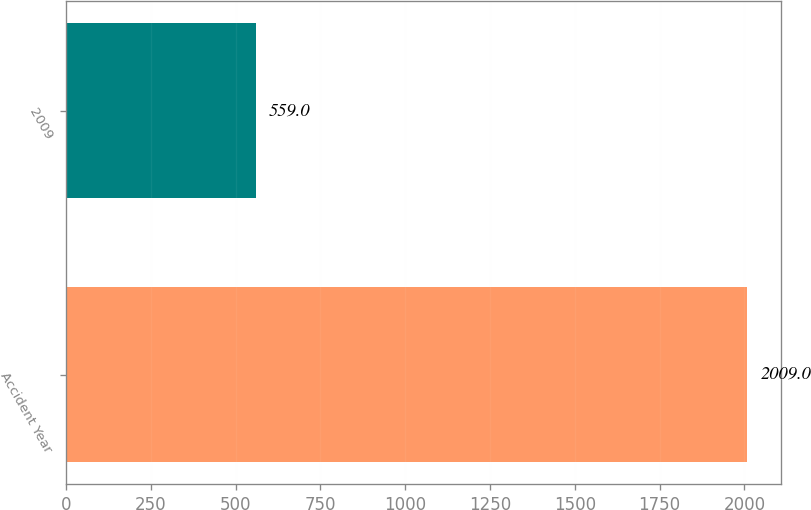Convert chart. <chart><loc_0><loc_0><loc_500><loc_500><bar_chart><fcel>Accident Year<fcel>2009<nl><fcel>2009<fcel>559<nl></chart> 